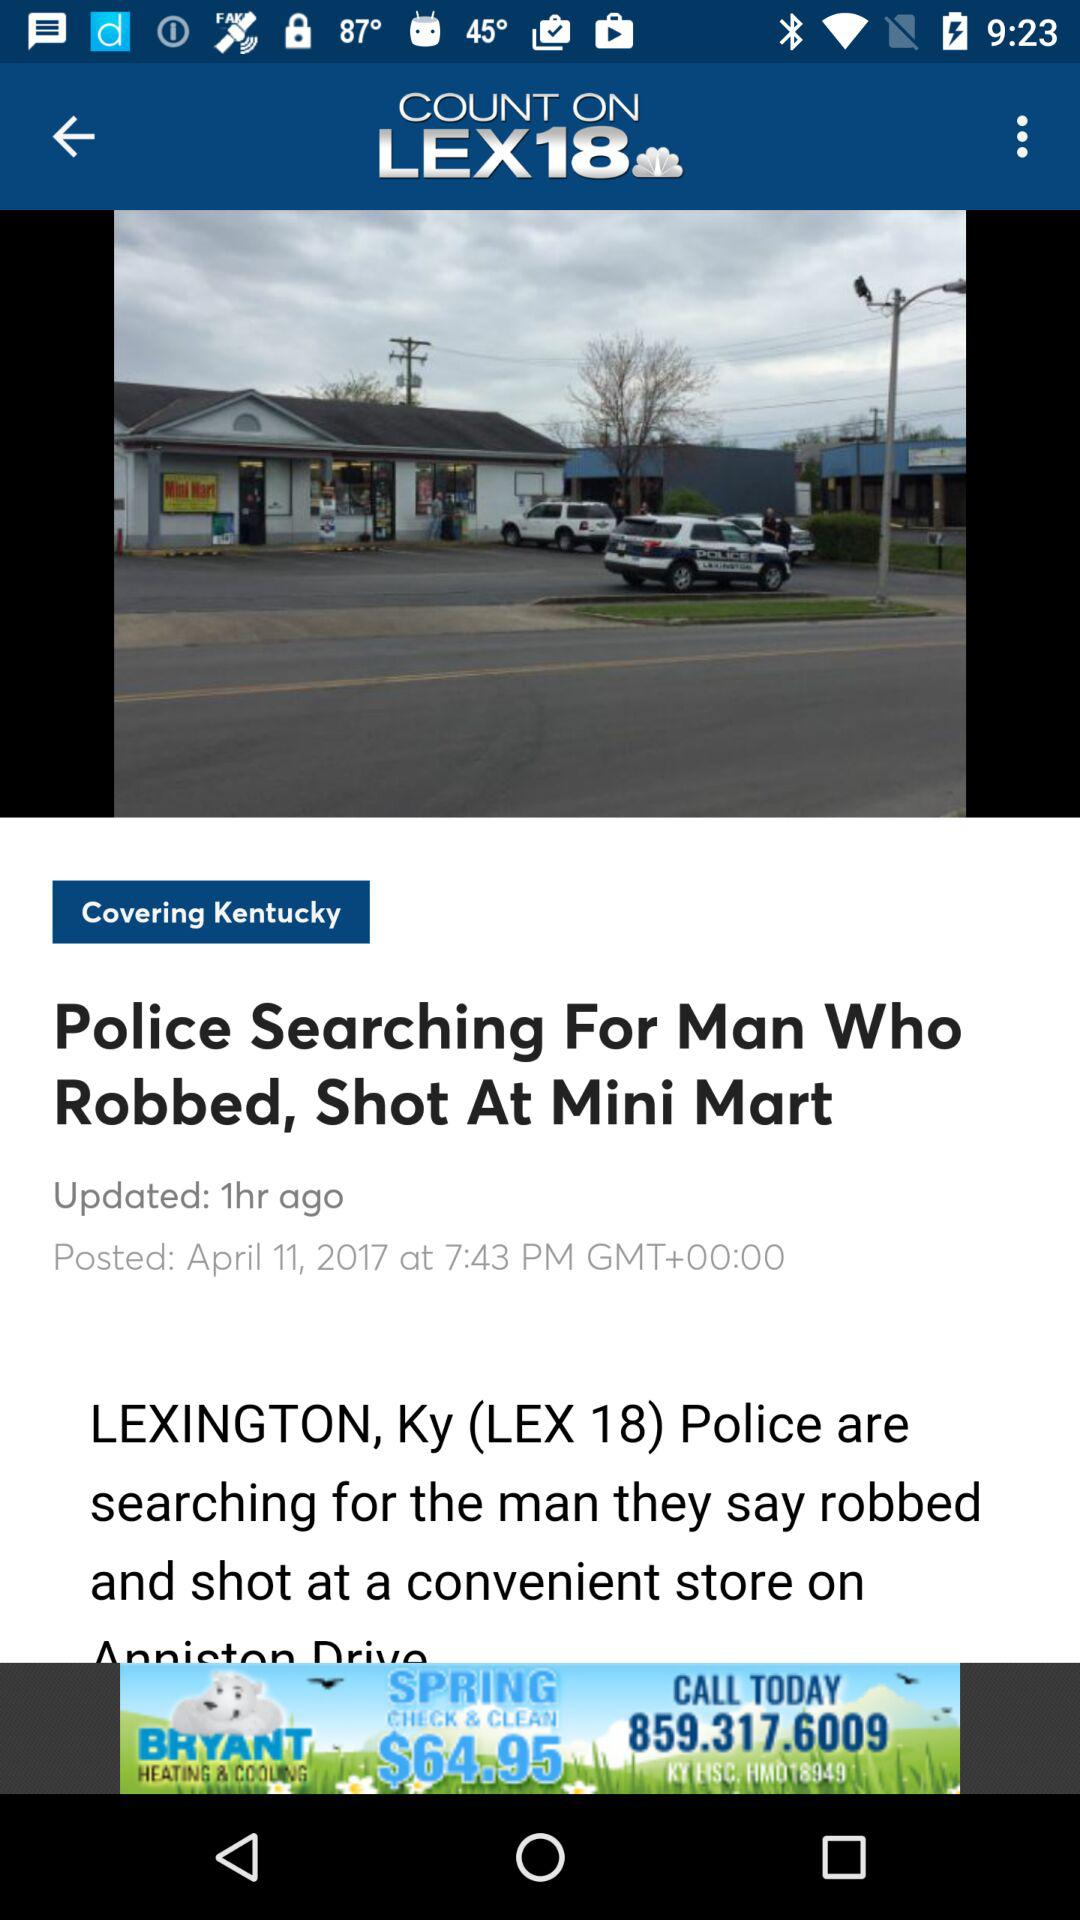When was the article posted? The article was posted on April 11, 2017 at 7:43 PM GMT+00:00. 